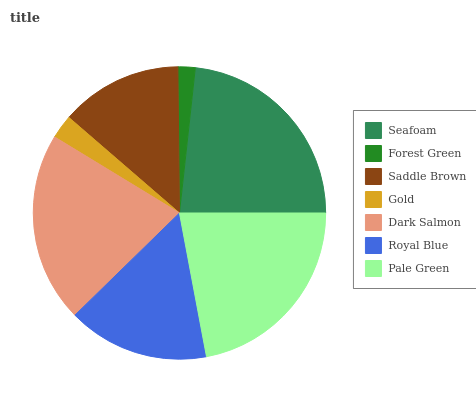Is Forest Green the minimum?
Answer yes or no. Yes. Is Seafoam the maximum?
Answer yes or no. Yes. Is Saddle Brown the minimum?
Answer yes or no. No. Is Saddle Brown the maximum?
Answer yes or no. No. Is Saddle Brown greater than Forest Green?
Answer yes or no. Yes. Is Forest Green less than Saddle Brown?
Answer yes or no. Yes. Is Forest Green greater than Saddle Brown?
Answer yes or no. No. Is Saddle Brown less than Forest Green?
Answer yes or no. No. Is Royal Blue the high median?
Answer yes or no. Yes. Is Royal Blue the low median?
Answer yes or no. Yes. Is Gold the high median?
Answer yes or no. No. Is Saddle Brown the low median?
Answer yes or no. No. 